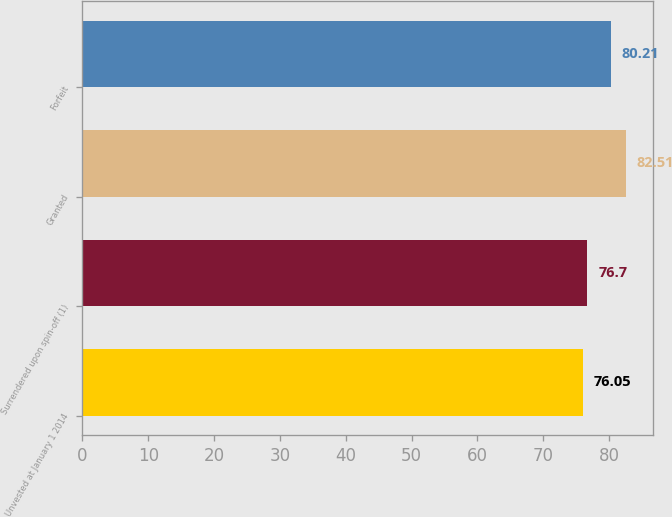Convert chart. <chart><loc_0><loc_0><loc_500><loc_500><bar_chart><fcel>Unvested at January 1 2014<fcel>Surrendered upon spin-off (1)<fcel>Granted<fcel>Forfeit<nl><fcel>76.05<fcel>76.7<fcel>82.51<fcel>80.21<nl></chart> 